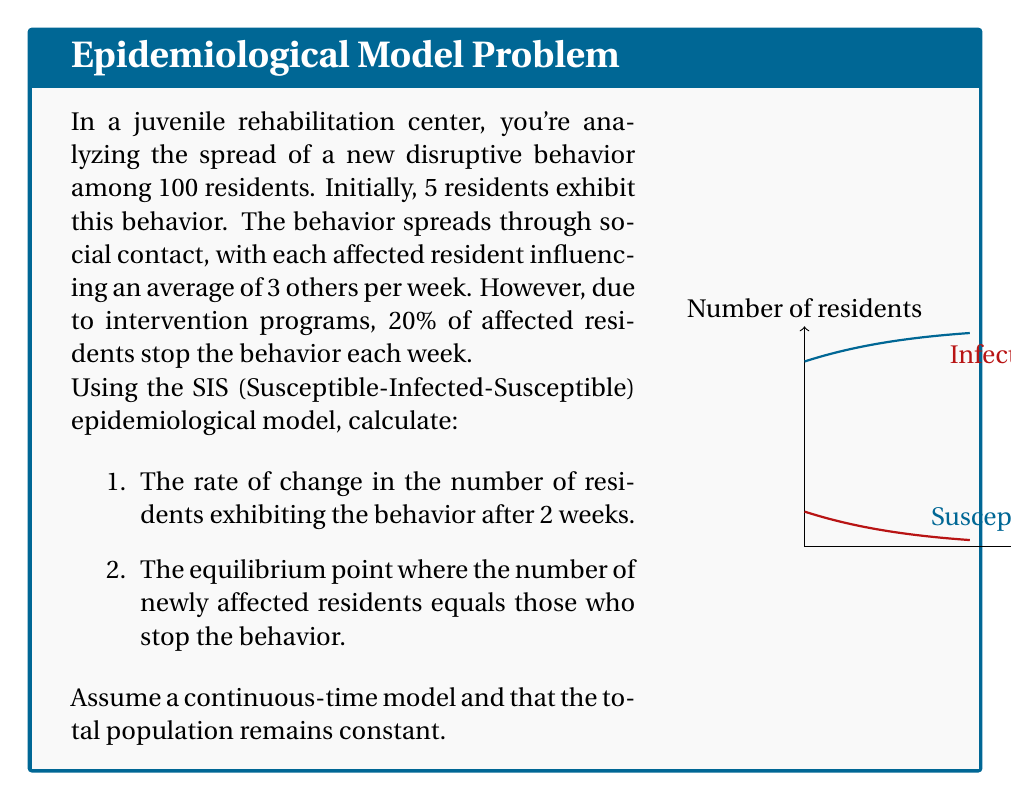Could you help me with this problem? Let's approach this step-by-step using the SIS model:

1) First, we need to set up our equations. Let $S$ be the number of susceptible residents and $I$ be the number of infected (exhibiting the behavior) residents.

   $$\frac{dS}{dt} = -\beta SI/N + \gamma I$$
   $$\frac{dI}{dt} = \beta SI/N - \gamma I$$

   Where:
   $N = 100$ (total population)
   $\beta = 3$ (infection rate per week)
   $\gamma = 0.2$ (recovery rate per week)

2) We're interested in $\frac{dI}{dt}$ after 2 weeks. To find this, we need to know $S$ and $I$ at $t=2$.

3) We can use the formula for $I(t)$ in the SIS model:

   $$I(t) = \frac{N}{1 + (\frac{N}{I_0} - 1)e^{-(\beta - \gamma)t}}$$

   Where $I_0 = 5$ (initial infected)

4) Plugging in our values:

   $$I(2) = \frac{100}{1 + (\frac{100}{5} - 1)e^{-(3 - 0.2)2}} \approx 61.65$$

5) Therefore, $S(2) = 100 - 61.65 = 38.35$

6) Now we can calculate $\frac{dI}{dt}$ at $t=2$:

   $$\frac{dI}{dt} = \beta SI/N - \gamma I = 3 * 38.35 * 61.65 / 100 - 0.2 * 61.65 \approx 58.85$$

7) For the equilibrium point, we set $\frac{dI}{dt} = 0$:

   $$\beta SI/N - \gamma I = 0$$
   $$\beta S/N = \gamma$$
   $$S = \gamma N / \beta = 0.2 * 100 / 3 \approx 6.67$$

8) Therefore, $I = 100 - 6.67 = 93.33$ at equilibrium.
Answer: 1) $\frac{dI}{dt} \approx 58.85$ residents/week after 2 weeks
2) Equilibrium: $S \approx 6.67$, $I \approx 93.33$ residents 